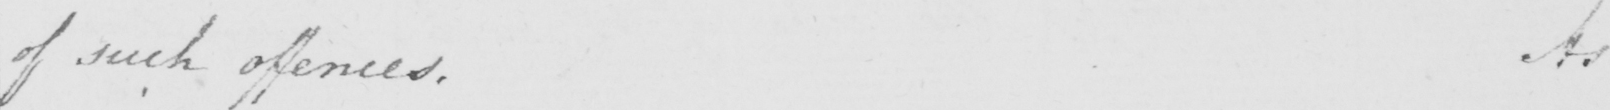Please transcribe the handwritten text in this image. of such offences. As 